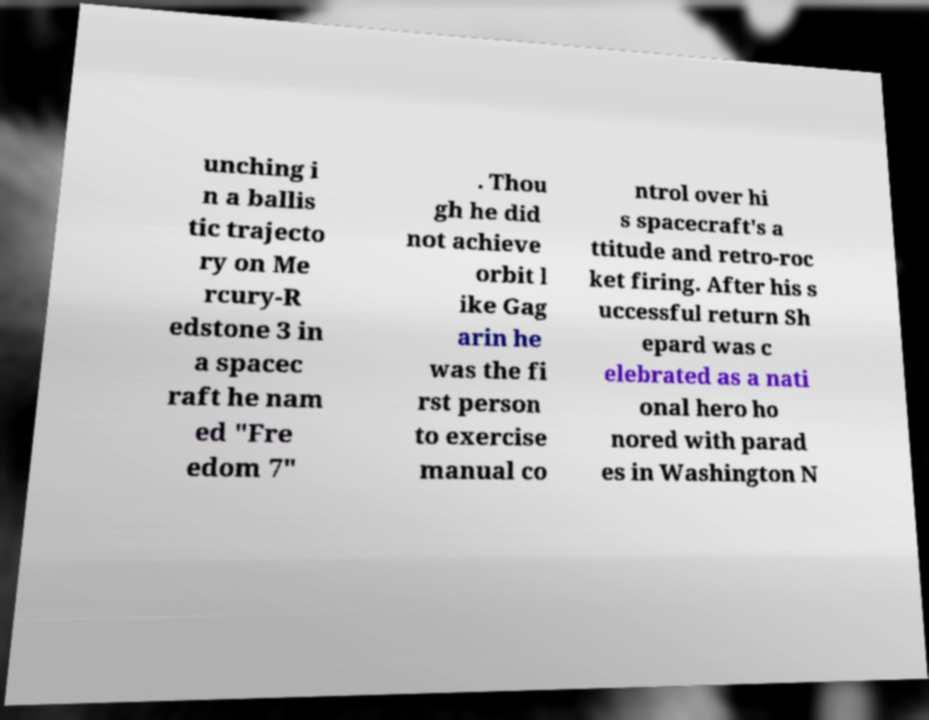Could you extract and type out the text from this image? unching i n a ballis tic trajecto ry on Me rcury-R edstone 3 in a spacec raft he nam ed "Fre edom 7" . Thou gh he did not achieve orbit l ike Gag arin he was the fi rst person to exercise manual co ntrol over hi s spacecraft's a ttitude and retro-roc ket firing. After his s uccessful return Sh epard was c elebrated as a nati onal hero ho nored with parad es in Washington N 